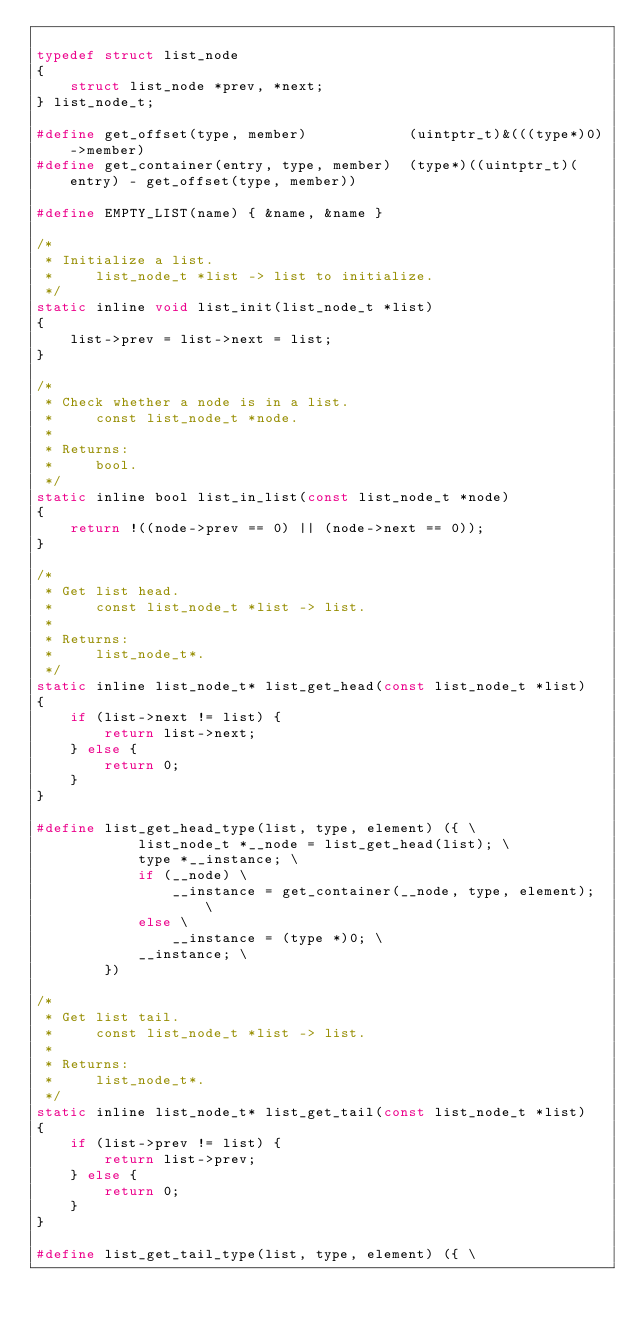Convert code to text. <code><loc_0><loc_0><loc_500><loc_500><_C_>
typedef struct list_node
{
    struct list_node *prev, *next;
} list_node_t;

#define get_offset(type, member)            (uintptr_t)&(((type*)0)->member)
#define get_container(entry, type, member)  (type*)((uintptr_t)(entry) - get_offset(type, member))

#define EMPTY_LIST(name) { &name, &name }

/*
 * Initialize a list.
 *     list_node_t *list -> list to initialize.
 */
static inline void list_init(list_node_t *list)
{
    list->prev = list->next = list;
}

/*
 * Check whether a node is in a list.
 *     const list_node_t *node.
 *
 * Returns:
 *     bool.
 */
static inline bool list_in_list(const list_node_t *node)
{
    return !((node->prev == 0) || (node->next == 0));
}

/*
 * Get list head.
 *     const list_node_t *list -> list.
 *
 * Returns:
 *     list_node_t*.
 */
static inline list_node_t* list_get_head(const list_node_t *list)
{
    if (list->next != list) {
        return list->next;
    } else {
        return 0;
    }
}

#define list_get_head_type(list, type, element) ({ \
            list_node_t *__node = list_get_head(list); \
            type *__instance; \
            if (__node) \
                __instance = get_container(__node, type, element); \
            else \
                __instance = (type *)0; \
            __instance; \
        })

/*
 * Get list tail.
 *     const list_node_t *list -> list.
 *
 * Returns:
 *     list_node_t*.
 */
static inline list_node_t* list_get_tail(const list_node_t *list)
{
    if (list->prev != list) {
        return list->prev;
    } else {
        return 0;
    }
}

#define list_get_tail_type(list, type, element) ({ \</code> 